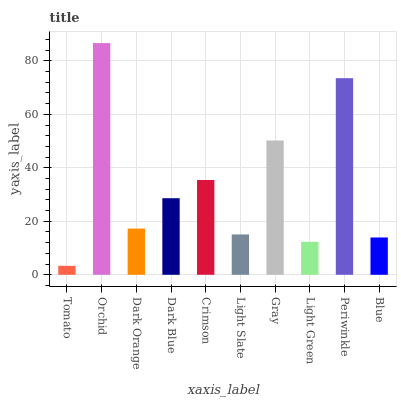Is Tomato the minimum?
Answer yes or no. Yes. Is Orchid the maximum?
Answer yes or no. Yes. Is Dark Orange the minimum?
Answer yes or no. No. Is Dark Orange the maximum?
Answer yes or no. No. Is Orchid greater than Dark Orange?
Answer yes or no. Yes. Is Dark Orange less than Orchid?
Answer yes or no. Yes. Is Dark Orange greater than Orchid?
Answer yes or no. No. Is Orchid less than Dark Orange?
Answer yes or no. No. Is Dark Blue the high median?
Answer yes or no. Yes. Is Dark Orange the low median?
Answer yes or no. Yes. Is Orchid the high median?
Answer yes or no. No. Is Orchid the low median?
Answer yes or no. No. 